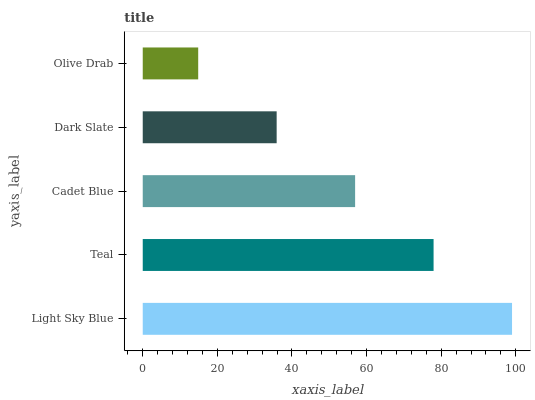Is Olive Drab the minimum?
Answer yes or no. Yes. Is Light Sky Blue the maximum?
Answer yes or no. Yes. Is Teal the minimum?
Answer yes or no. No. Is Teal the maximum?
Answer yes or no. No. Is Light Sky Blue greater than Teal?
Answer yes or no. Yes. Is Teal less than Light Sky Blue?
Answer yes or no. Yes. Is Teal greater than Light Sky Blue?
Answer yes or no. No. Is Light Sky Blue less than Teal?
Answer yes or no. No. Is Cadet Blue the high median?
Answer yes or no. Yes. Is Cadet Blue the low median?
Answer yes or no. Yes. Is Light Sky Blue the high median?
Answer yes or no. No. Is Light Sky Blue the low median?
Answer yes or no. No. 